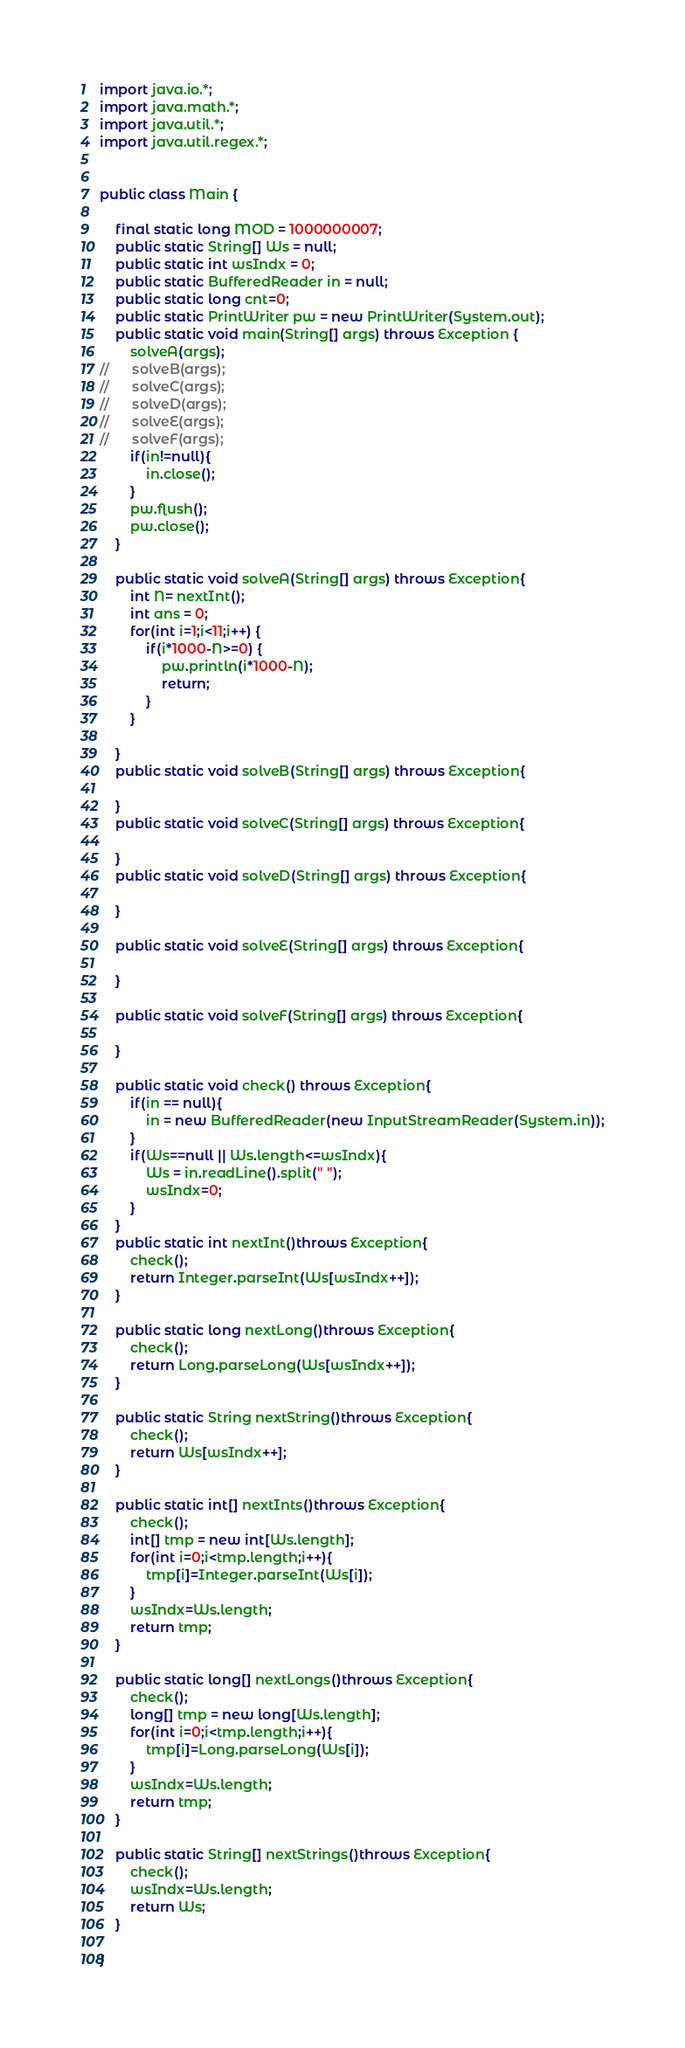<code> <loc_0><loc_0><loc_500><loc_500><_Java_>import java.io.*;
import java.math.*;
import java.util.*;
import java.util.regex.*;


public class Main {

	final static long MOD = 1000000007;
	public static String[] Ws = null;
	public static int wsIndx = 0;
	public static BufferedReader in = null;
	public static long cnt=0;
	public static PrintWriter pw = new PrintWriter(System.out);
	public static void main(String[] args) throws Exception {
		solveA(args);
//		solveB(args);
//		solveC(args);
//		solveD(args);
//		solveE(args);
//		solveF(args);
		if(in!=null){
			in.close();
		}
		pw.flush();
		pw.close();
	}

	public static void solveA(String[] args) throws Exception{
		int N= nextInt();
		int ans = 0;
		for(int i=1;i<11;i++) {
			if(i*1000-N>=0) {
				pw.println(i*1000-N);
				return;
			}
		}

	}
	public static void solveB(String[] args) throws Exception{

	}
	public static void solveC(String[] args) throws Exception{

	}
	public static void solveD(String[] args) throws Exception{

	}

	public static void solveE(String[] args) throws Exception{

	}

	public static void solveF(String[] args) throws Exception{

	}

	public static void check() throws Exception{
		if(in == null){
			in = new BufferedReader(new InputStreamReader(System.in));
		}
		if(Ws==null || Ws.length<=wsIndx){
			Ws = in.readLine().split(" ");
			wsIndx=0;
		}
	}
	public static int nextInt()throws Exception{
		check();
		return Integer.parseInt(Ws[wsIndx++]);
	}

	public static long nextLong()throws Exception{
		check();
		return Long.parseLong(Ws[wsIndx++]);
	}

	public static String nextString()throws Exception{
		check();
		return Ws[wsIndx++];
	}

	public static int[] nextInts()throws Exception{
		check();
		int[] tmp = new int[Ws.length];
		for(int i=0;i<tmp.length;i++){
			tmp[i]=Integer.parseInt(Ws[i]);
		}
		wsIndx=Ws.length;
		return tmp;
	}

	public static long[] nextLongs()throws Exception{
		check();
		long[] tmp = new long[Ws.length];
		for(int i=0;i<tmp.length;i++){
			tmp[i]=Long.parseLong(Ws[i]);
		}
		wsIndx=Ws.length;
		return tmp;
	}

	public static String[] nextStrings()throws Exception{
		check();
		wsIndx=Ws.length;
		return Ws;
	}

}

</code> 